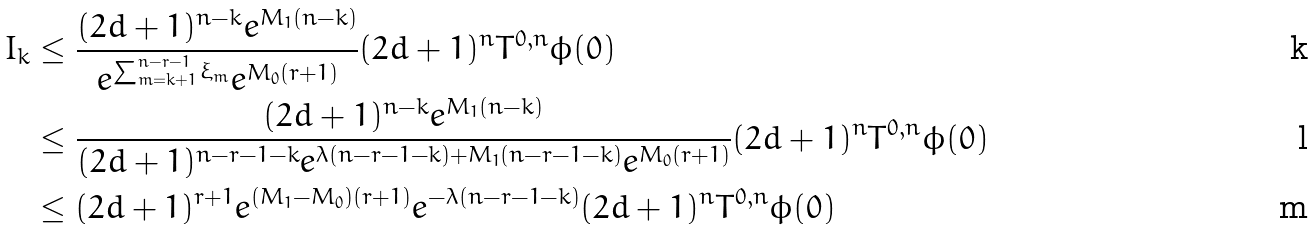Convert formula to latex. <formula><loc_0><loc_0><loc_500><loc_500>I _ { k } & \leq \frac { ( 2 d + 1 ) ^ { n - k } e ^ { M _ { 1 } ( n - k ) } } { e ^ { \sum _ { m = k + 1 } ^ { n - r - 1 } \xi _ { m } } e ^ { M _ { 0 } ( r + 1 ) } } ( 2 d + 1 ) ^ { n } T ^ { 0 , n } \phi ( 0 ) \\ & \leq \frac { ( 2 d + 1 ) ^ { n - k } e ^ { M _ { 1 } ( n - k ) } } { ( 2 d + 1 ) ^ { n - r - 1 - k } e ^ { \lambda ( n - r - 1 - k ) + M _ { 1 } ( n - r - 1 - k ) } e ^ { M _ { 0 } ( r + 1 ) } } ( 2 d + 1 ) ^ { n } T ^ { 0 , n } \phi ( 0 ) \\ & \leq ( 2 d + 1 ) ^ { r + 1 } e ^ { ( M _ { 1 } - M _ { 0 } ) ( r + 1 ) } e ^ { - \lambda ( n - r - 1 - k ) } ( 2 d + 1 ) ^ { n } T ^ { 0 , n } \phi ( 0 )</formula> 